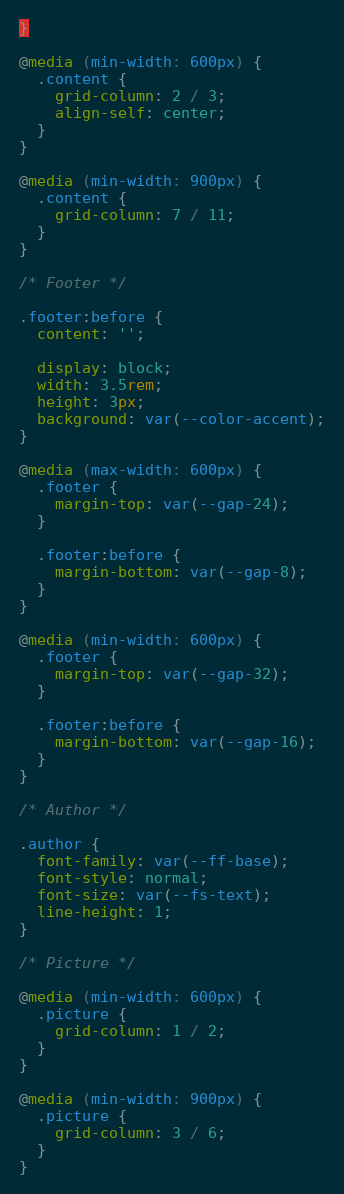Convert code to text. <code><loc_0><loc_0><loc_500><loc_500><_CSS_>}

@media (min-width: 600px) {
  .content {
    grid-column: 2 / 3;
    align-self: center;
  }
}

@media (min-width: 900px) {
  .content {
    grid-column: 7 / 11;
  }
}

/* Footer */

.footer:before {
  content: '';

  display: block;
  width: 3.5rem;
  height: 3px;
  background: var(--color-accent);
}

@media (max-width: 600px) {
  .footer {
    margin-top: var(--gap-24);
  }

  .footer:before {
    margin-bottom: var(--gap-8);
  }
}

@media (min-width: 600px) {
  .footer {
    margin-top: var(--gap-32);
  }

  .footer:before {
    margin-bottom: var(--gap-16);
  }
}

/* Author */

.author {
  font-family: var(--ff-base);
  font-style: normal;
  font-size: var(--fs-text);
  line-height: 1;
}

/* Picture */

@media (min-width: 600px) {
  .picture {
    grid-column: 1 / 2;
  }
}

@media (min-width: 900px) {
  .picture {
    grid-column: 3 / 6;
  }
}</code> 